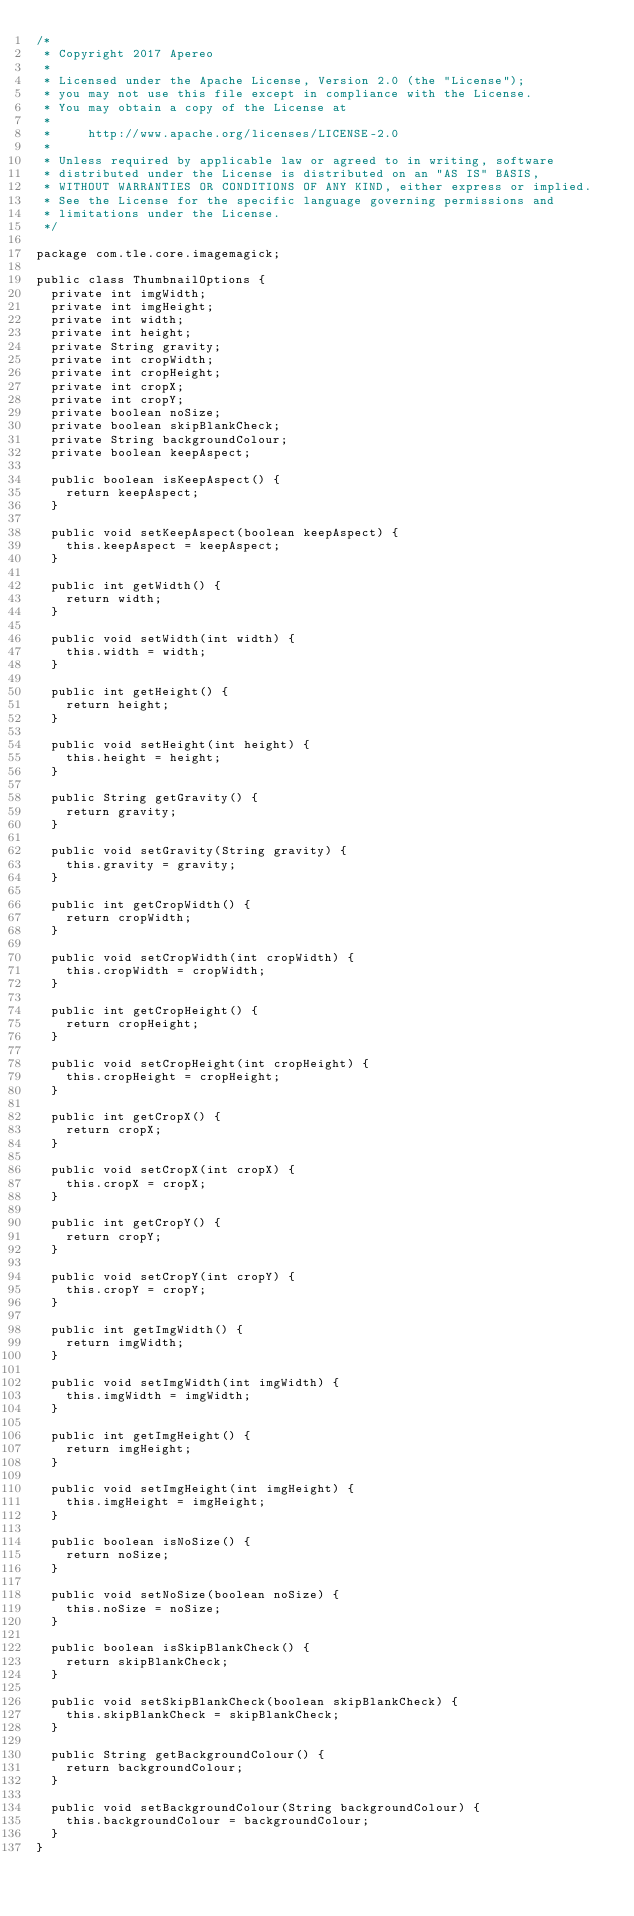<code> <loc_0><loc_0><loc_500><loc_500><_Java_>/*
 * Copyright 2017 Apereo
 *
 * Licensed under the Apache License, Version 2.0 (the "License");
 * you may not use this file except in compliance with the License.
 * You may obtain a copy of the License at
 *
 *     http://www.apache.org/licenses/LICENSE-2.0
 *
 * Unless required by applicable law or agreed to in writing, software
 * distributed under the License is distributed on an "AS IS" BASIS,
 * WITHOUT WARRANTIES OR CONDITIONS OF ANY KIND, either express or implied.
 * See the License for the specific language governing permissions and
 * limitations under the License.
 */

package com.tle.core.imagemagick;

public class ThumbnailOptions {
  private int imgWidth;
  private int imgHeight;
  private int width;
  private int height;
  private String gravity;
  private int cropWidth;
  private int cropHeight;
  private int cropX;
  private int cropY;
  private boolean noSize;
  private boolean skipBlankCheck;
  private String backgroundColour;
  private boolean keepAspect;

  public boolean isKeepAspect() {
    return keepAspect;
  }

  public void setKeepAspect(boolean keepAspect) {
    this.keepAspect = keepAspect;
  }

  public int getWidth() {
    return width;
  }

  public void setWidth(int width) {
    this.width = width;
  }

  public int getHeight() {
    return height;
  }

  public void setHeight(int height) {
    this.height = height;
  }

  public String getGravity() {
    return gravity;
  }

  public void setGravity(String gravity) {
    this.gravity = gravity;
  }

  public int getCropWidth() {
    return cropWidth;
  }

  public void setCropWidth(int cropWidth) {
    this.cropWidth = cropWidth;
  }

  public int getCropHeight() {
    return cropHeight;
  }

  public void setCropHeight(int cropHeight) {
    this.cropHeight = cropHeight;
  }

  public int getCropX() {
    return cropX;
  }

  public void setCropX(int cropX) {
    this.cropX = cropX;
  }

  public int getCropY() {
    return cropY;
  }

  public void setCropY(int cropY) {
    this.cropY = cropY;
  }

  public int getImgWidth() {
    return imgWidth;
  }

  public void setImgWidth(int imgWidth) {
    this.imgWidth = imgWidth;
  }

  public int getImgHeight() {
    return imgHeight;
  }

  public void setImgHeight(int imgHeight) {
    this.imgHeight = imgHeight;
  }

  public boolean isNoSize() {
    return noSize;
  }

  public void setNoSize(boolean noSize) {
    this.noSize = noSize;
  }

  public boolean isSkipBlankCheck() {
    return skipBlankCheck;
  }

  public void setSkipBlankCheck(boolean skipBlankCheck) {
    this.skipBlankCheck = skipBlankCheck;
  }

  public String getBackgroundColour() {
    return backgroundColour;
  }

  public void setBackgroundColour(String backgroundColour) {
    this.backgroundColour = backgroundColour;
  }
}
</code> 